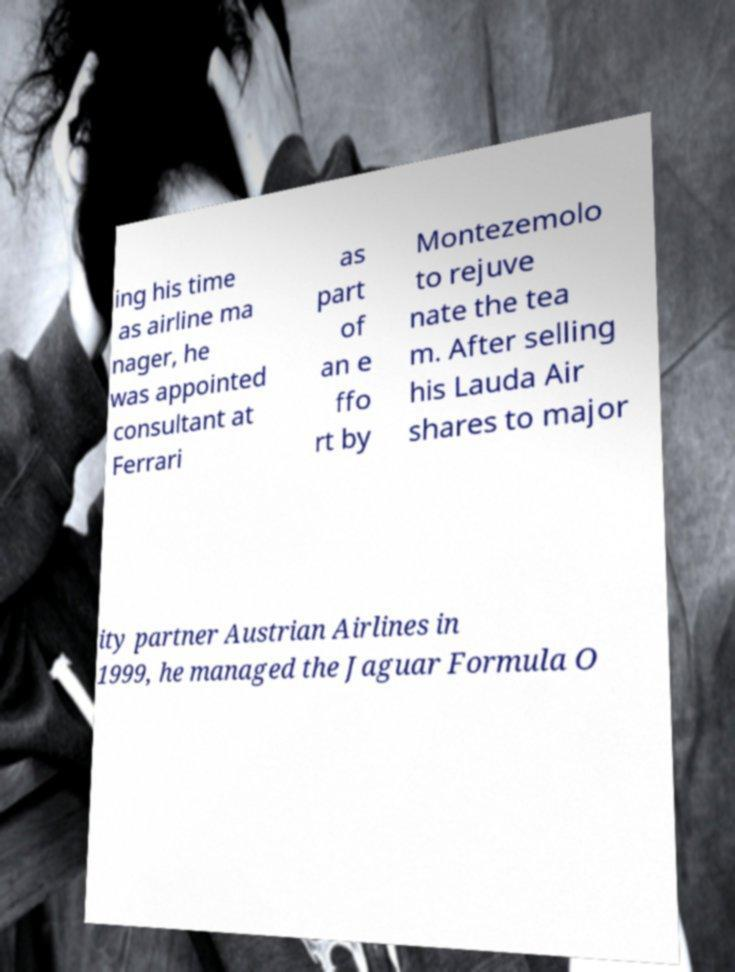Please read and relay the text visible in this image. What does it say? ing his time as airline ma nager, he was appointed consultant at Ferrari as part of an e ffo rt by Montezemolo to rejuve nate the tea m. After selling his Lauda Air shares to major ity partner Austrian Airlines in 1999, he managed the Jaguar Formula O 